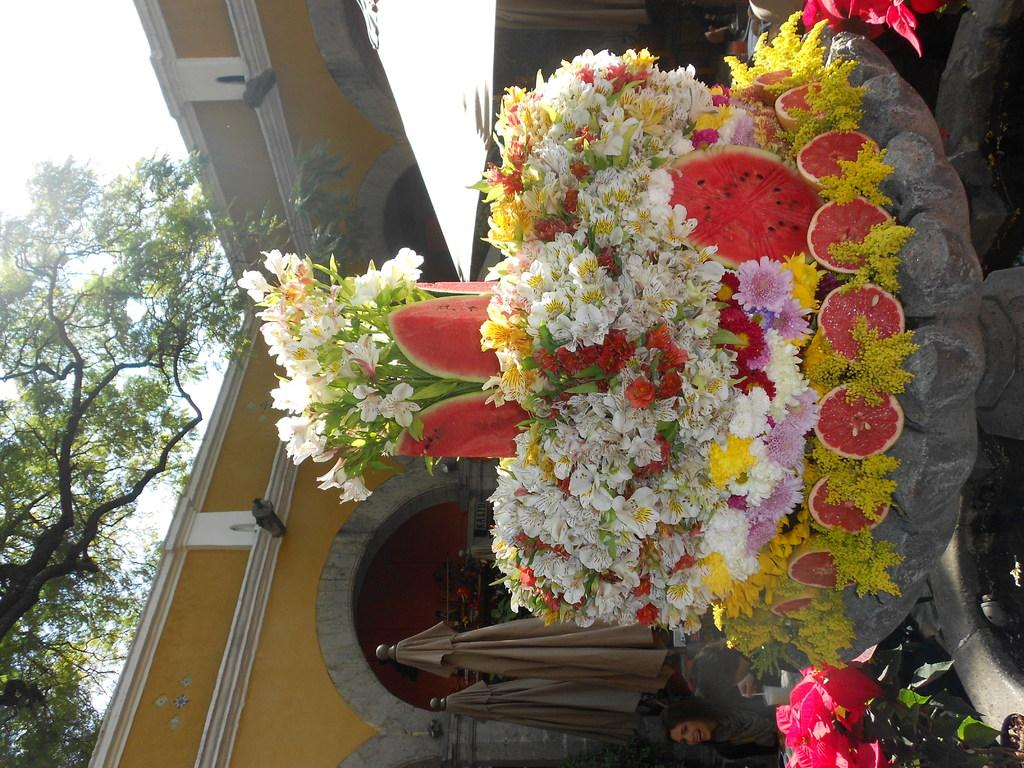What type of plants can be seen in the image? There are flowers in the image. What colors are the flowers? The flowers are in multiple colors. What can be seen in the background of the image? There is a wall and trees in the background of the image. What color is the wall? The wall is yellow. What color are the trees? The trees are green. What color is the sky in the image? The sky is white in the image. How many stations are visible in the image? There are no stations present in the image. What is the distance between the flowers and the trees in the image? The image is a photograph, so it does not have a measurable distance between the flowers and trees. 